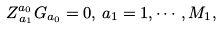<formula> <loc_0><loc_0><loc_500><loc_500>Z _ { \, a _ { 1 } } ^ { a _ { 0 } } G _ { a _ { 0 } } = 0 , \, a _ { 1 } = 1 , \cdots , M _ { 1 } ,</formula> 